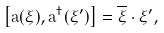<formula> <loc_0><loc_0><loc_500><loc_500>\left [ \tilde { a } ( \xi ) , \tilde { a } ^ { \dagger } ( \xi ^ { \prime } ) \right ] = \overline { \xi } \cdot \xi ^ { \prime } ,</formula> 